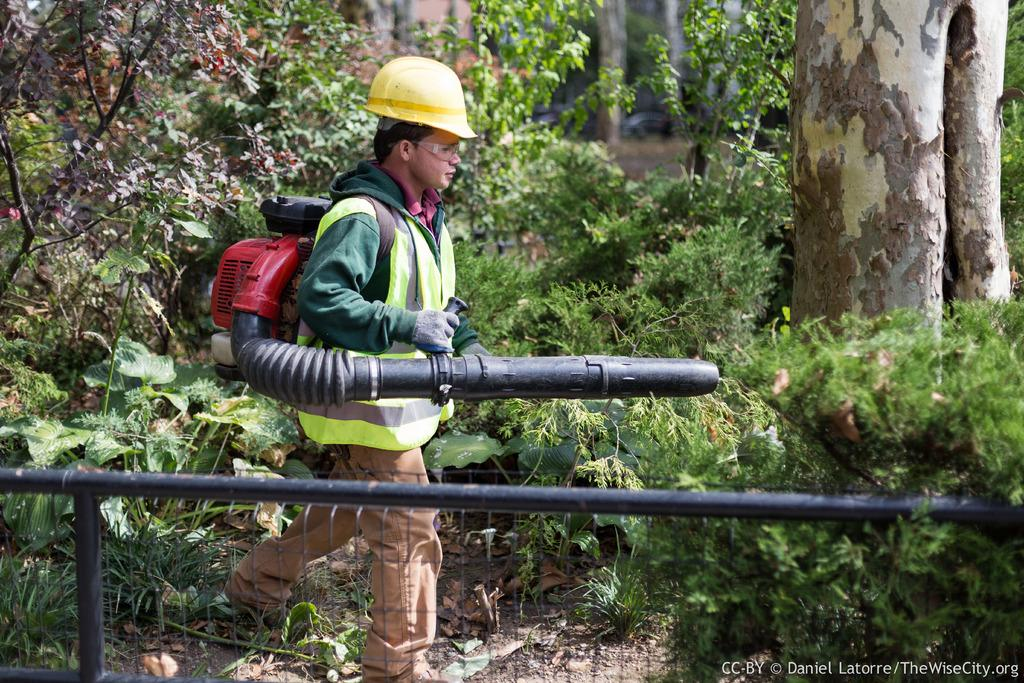Who is present in the image? There is a man in the image. What is the man wearing? The man is wearing some equipment bag. What is the man doing in the image? The man is walking on the land. What can be seen in the surroundings of the man? There are plants and trees around the man. What type of war is depicted in the image? There is no war depicted in the image; it features a man walking on the land with plants and trees around him. What cast member is missing from the image? There is no reference to a cast or any actors in the image, so it's not possible to determine if any cast members are missing. 